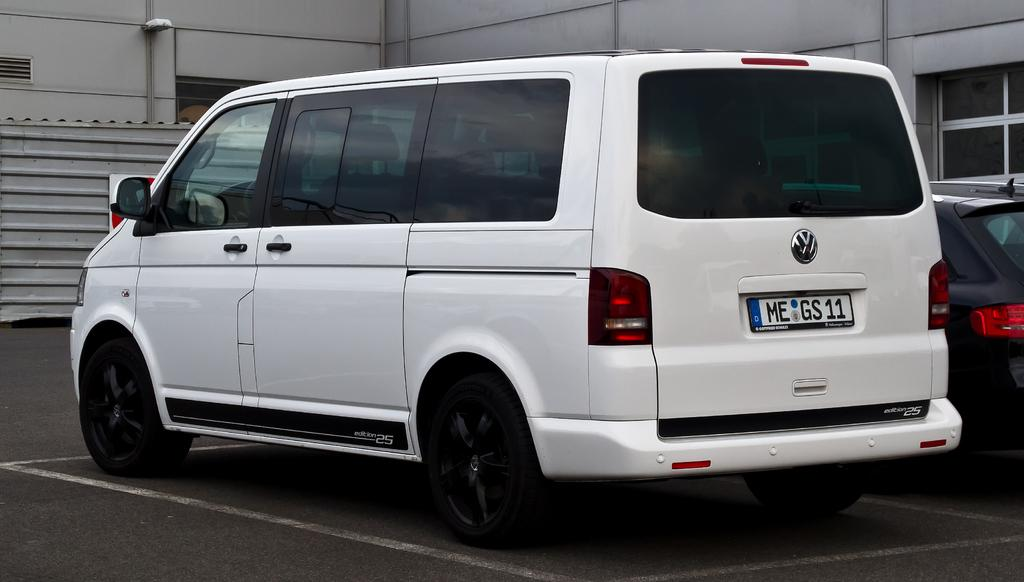<image>
Share a concise interpretation of the image provided. A white van with tinted windows and a number plate starting with ME is parked in a car park. 